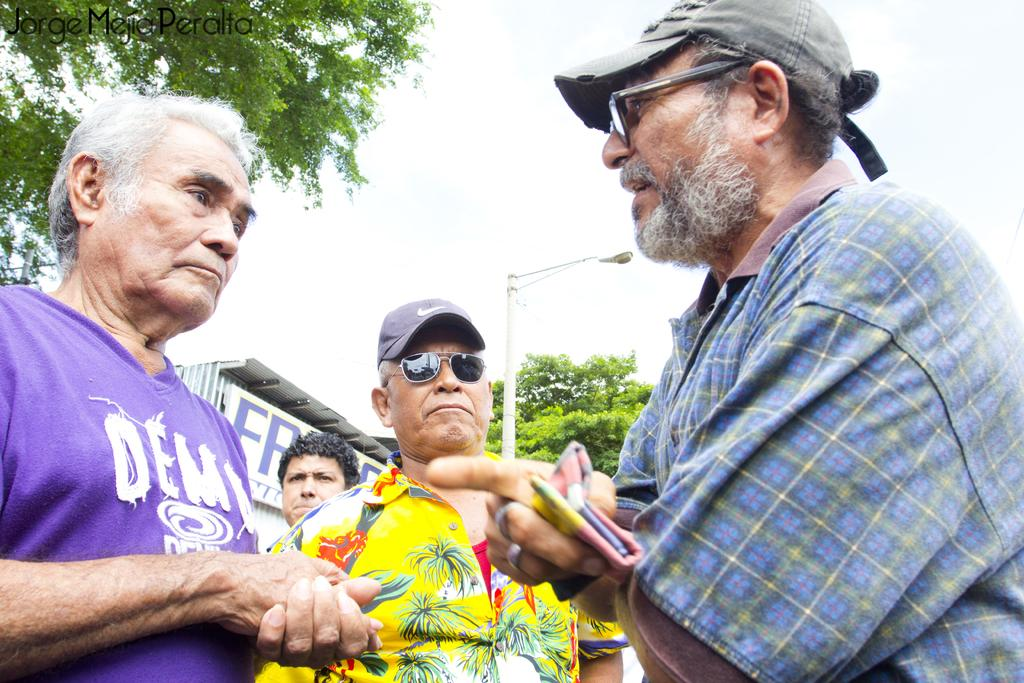What can be seen in the image? There are people standing in the image. What structures or objects can be seen in the background of the image? There is a shed, a pole, and trees in the background of the image. What else is visible in the background of the image? The sky is visible in the background of the image. What type of marble is being used to build the shed in the image? There is no mention of marble in the image, and the shed appears to be made of wood or another material. 